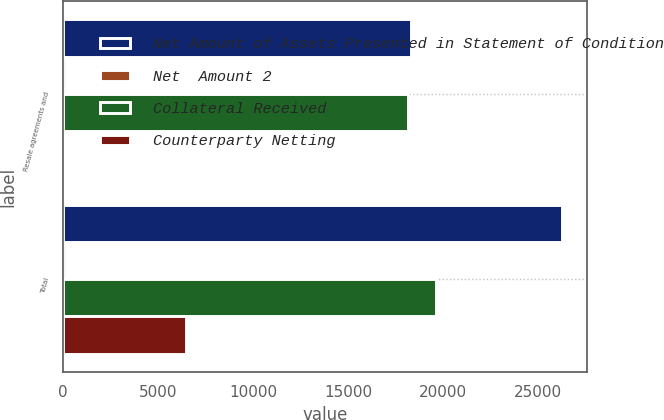<chart> <loc_0><loc_0><loc_500><loc_500><stacked_bar_chart><ecel><fcel>Resale agreements and<fcel>Total<nl><fcel>Net Amount of Assets Presented in Statement of Condition<fcel>18331<fcel>26265<nl><fcel>Net  Amount 2<fcel>128<fcel>128<nl><fcel>Collateral Received<fcel>18157<fcel>19647<nl><fcel>Counterparty Netting<fcel>46<fcel>6490<nl></chart> 